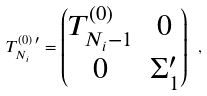Convert formula to latex. <formula><loc_0><loc_0><loc_500><loc_500>T _ { N _ { i } } ^ { ( 0 ) \, \prime } = \begin{pmatrix} T ^ { ( 0 ) } _ { N _ { i } - 1 } & 0 \\ 0 & \Sigma _ { 1 } ^ { \prime } \end{pmatrix} \ ,</formula> 